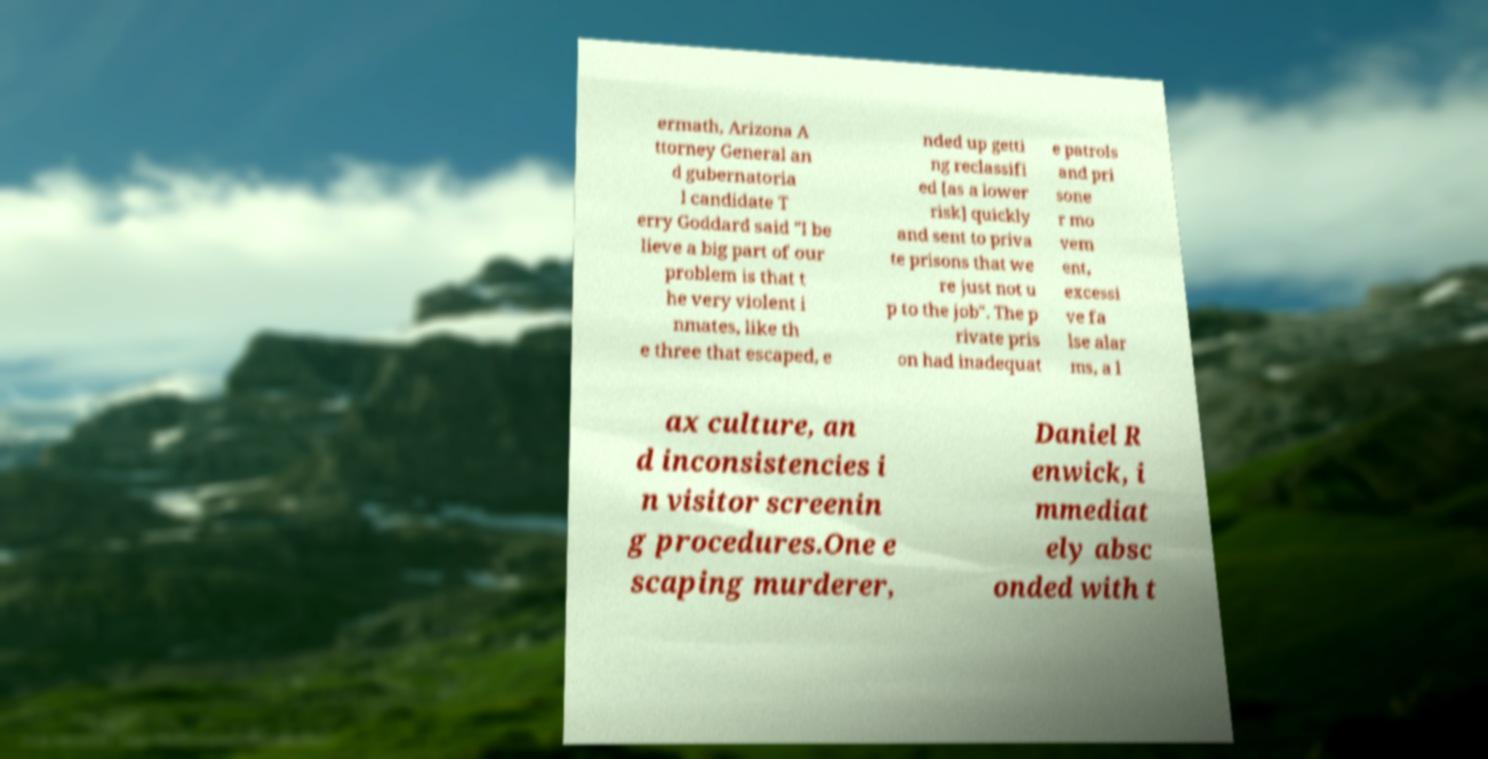There's text embedded in this image that I need extracted. Can you transcribe it verbatim? ermath, Arizona A ttorney General an d gubernatoria l candidate T erry Goddard said "I be lieve a big part of our problem is that t he very violent i nmates, like th e three that escaped, e nded up getti ng reclassifi ed [as a lower risk] quickly and sent to priva te prisons that we re just not u p to the job". The p rivate pris on had inadequat e patrols and pri sone r mo vem ent, excessi ve fa lse alar ms, a l ax culture, an d inconsistencies i n visitor screenin g procedures.One e scaping murderer, Daniel R enwick, i mmediat ely absc onded with t 